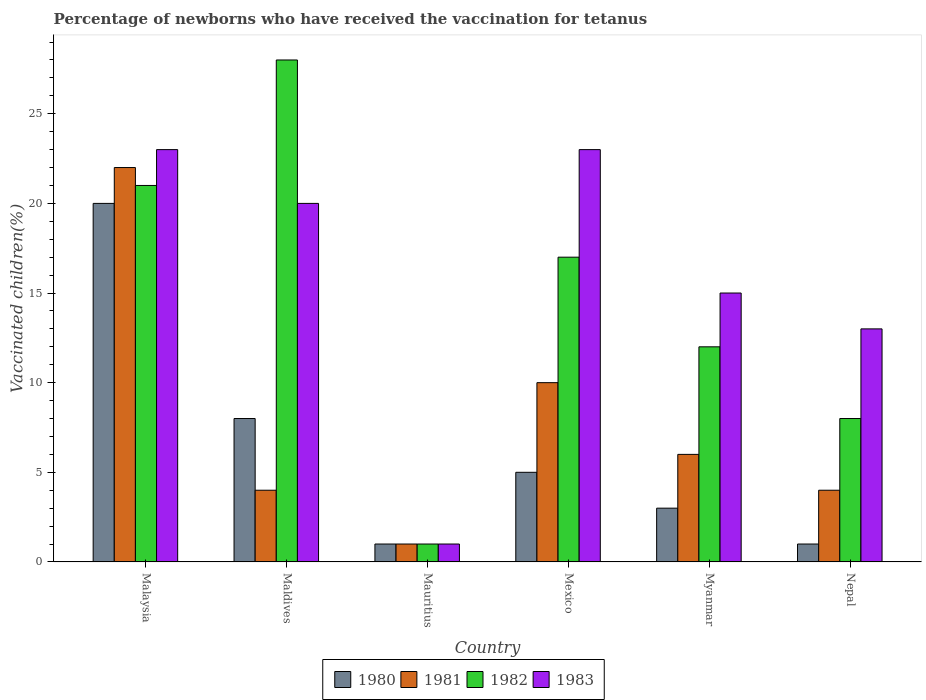Are the number of bars per tick equal to the number of legend labels?
Your response must be concise. Yes. Are the number of bars on each tick of the X-axis equal?
Provide a short and direct response. Yes. How many bars are there on the 3rd tick from the right?
Provide a succinct answer. 4. What is the label of the 6th group of bars from the left?
Make the answer very short. Nepal. What is the percentage of vaccinated children in 1981 in Myanmar?
Your answer should be very brief. 6. In which country was the percentage of vaccinated children in 1982 maximum?
Your answer should be compact. Maldives. In which country was the percentage of vaccinated children in 1983 minimum?
Give a very brief answer. Mauritius. What is the average percentage of vaccinated children in 1980 per country?
Provide a short and direct response. 6.33. What is the difference between the percentage of vaccinated children of/in 1981 and percentage of vaccinated children of/in 1982 in Nepal?
Offer a very short reply. -4. In how many countries, is the percentage of vaccinated children in 1982 greater than 8 %?
Offer a terse response. 4. How many bars are there?
Your answer should be compact. 24. Are the values on the major ticks of Y-axis written in scientific E-notation?
Your answer should be compact. No. How many legend labels are there?
Offer a very short reply. 4. How are the legend labels stacked?
Offer a terse response. Horizontal. What is the title of the graph?
Make the answer very short. Percentage of newborns who have received the vaccination for tetanus. Does "2005" appear as one of the legend labels in the graph?
Your answer should be compact. No. What is the label or title of the X-axis?
Make the answer very short. Country. What is the label or title of the Y-axis?
Your answer should be compact. Vaccinated children(%). What is the Vaccinated children(%) in 1981 in Malaysia?
Give a very brief answer. 22. What is the Vaccinated children(%) of 1980 in Maldives?
Offer a very short reply. 8. What is the Vaccinated children(%) in 1981 in Maldives?
Your answer should be compact. 4. What is the Vaccinated children(%) of 1980 in Mauritius?
Provide a succinct answer. 1. What is the Vaccinated children(%) of 1983 in Mauritius?
Provide a short and direct response. 1. What is the Vaccinated children(%) in 1980 in Mexico?
Your response must be concise. 5. What is the Vaccinated children(%) in 1983 in Mexico?
Make the answer very short. 23. What is the Vaccinated children(%) of 1981 in Myanmar?
Keep it short and to the point. 6. What is the Vaccinated children(%) of 1982 in Myanmar?
Keep it short and to the point. 12. What is the Vaccinated children(%) of 1983 in Myanmar?
Give a very brief answer. 15. What is the Vaccinated children(%) of 1980 in Nepal?
Offer a very short reply. 1. What is the Vaccinated children(%) in 1981 in Nepal?
Make the answer very short. 4. Across all countries, what is the maximum Vaccinated children(%) of 1980?
Provide a short and direct response. 20. Across all countries, what is the maximum Vaccinated children(%) of 1982?
Your answer should be very brief. 28. Across all countries, what is the minimum Vaccinated children(%) of 1980?
Your response must be concise. 1. Across all countries, what is the minimum Vaccinated children(%) of 1982?
Offer a terse response. 1. What is the total Vaccinated children(%) of 1982 in the graph?
Keep it short and to the point. 87. What is the total Vaccinated children(%) of 1983 in the graph?
Offer a very short reply. 95. What is the difference between the Vaccinated children(%) in 1980 in Malaysia and that in Maldives?
Offer a very short reply. 12. What is the difference between the Vaccinated children(%) in 1981 in Malaysia and that in Maldives?
Give a very brief answer. 18. What is the difference between the Vaccinated children(%) of 1980 in Malaysia and that in Mauritius?
Provide a succinct answer. 19. What is the difference between the Vaccinated children(%) of 1983 in Malaysia and that in Mauritius?
Provide a short and direct response. 22. What is the difference between the Vaccinated children(%) in 1983 in Malaysia and that in Mexico?
Keep it short and to the point. 0. What is the difference between the Vaccinated children(%) in 1983 in Malaysia and that in Myanmar?
Make the answer very short. 8. What is the difference between the Vaccinated children(%) of 1980 in Malaysia and that in Nepal?
Keep it short and to the point. 19. What is the difference between the Vaccinated children(%) of 1982 in Malaysia and that in Nepal?
Give a very brief answer. 13. What is the difference between the Vaccinated children(%) in 1983 in Malaysia and that in Nepal?
Provide a succinct answer. 10. What is the difference between the Vaccinated children(%) of 1981 in Maldives and that in Mauritius?
Offer a very short reply. 3. What is the difference between the Vaccinated children(%) of 1982 in Maldives and that in Mauritius?
Provide a short and direct response. 27. What is the difference between the Vaccinated children(%) of 1982 in Maldives and that in Mexico?
Your answer should be compact. 11. What is the difference between the Vaccinated children(%) in 1983 in Maldives and that in Mexico?
Offer a terse response. -3. What is the difference between the Vaccinated children(%) in 1980 in Maldives and that in Myanmar?
Make the answer very short. 5. What is the difference between the Vaccinated children(%) of 1981 in Maldives and that in Myanmar?
Your answer should be compact. -2. What is the difference between the Vaccinated children(%) of 1983 in Maldives and that in Myanmar?
Offer a very short reply. 5. What is the difference between the Vaccinated children(%) of 1980 in Maldives and that in Nepal?
Your response must be concise. 7. What is the difference between the Vaccinated children(%) in 1982 in Maldives and that in Nepal?
Provide a short and direct response. 20. What is the difference between the Vaccinated children(%) of 1983 in Maldives and that in Nepal?
Make the answer very short. 7. What is the difference between the Vaccinated children(%) of 1980 in Mauritius and that in Mexico?
Ensure brevity in your answer.  -4. What is the difference between the Vaccinated children(%) in 1982 in Mauritius and that in Mexico?
Provide a succinct answer. -16. What is the difference between the Vaccinated children(%) in 1980 in Mauritius and that in Nepal?
Provide a short and direct response. 0. What is the difference between the Vaccinated children(%) of 1981 in Mauritius and that in Nepal?
Ensure brevity in your answer.  -3. What is the difference between the Vaccinated children(%) of 1982 in Mauritius and that in Nepal?
Your answer should be compact. -7. What is the difference between the Vaccinated children(%) in 1982 in Mexico and that in Myanmar?
Offer a very short reply. 5. What is the difference between the Vaccinated children(%) of 1981 in Mexico and that in Nepal?
Give a very brief answer. 6. What is the difference between the Vaccinated children(%) of 1983 in Mexico and that in Nepal?
Your answer should be very brief. 10. What is the difference between the Vaccinated children(%) in 1981 in Myanmar and that in Nepal?
Your answer should be compact. 2. What is the difference between the Vaccinated children(%) in 1983 in Myanmar and that in Nepal?
Your answer should be very brief. 2. What is the difference between the Vaccinated children(%) in 1980 in Malaysia and the Vaccinated children(%) in 1981 in Maldives?
Your response must be concise. 16. What is the difference between the Vaccinated children(%) in 1980 in Malaysia and the Vaccinated children(%) in 1983 in Maldives?
Make the answer very short. 0. What is the difference between the Vaccinated children(%) in 1982 in Malaysia and the Vaccinated children(%) in 1983 in Maldives?
Keep it short and to the point. 1. What is the difference between the Vaccinated children(%) in 1980 in Malaysia and the Vaccinated children(%) in 1981 in Mauritius?
Offer a terse response. 19. What is the difference between the Vaccinated children(%) of 1980 in Malaysia and the Vaccinated children(%) of 1982 in Mauritius?
Your response must be concise. 19. What is the difference between the Vaccinated children(%) in 1980 in Malaysia and the Vaccinated children(%) in 1983 in Mauritius?
Make the answer very short. 19. What is the difference between the Vaccinated children(%) of 1981 in Malaysia and the Vaccinated children(%) of 1982 in Mauritius?
Provide a succinct answer. 21. What is the difference between the Vaccinated children(%) in 1981 in Malaysia and the Vaccinated children(%) in 1983 in Mauritius?
Offer a terse response. 21. What is the difference between the Vaccinated children(%) of 1982 in Malaysia and the Vaccinated children(%) of 1983 in Mauritius?
Your answer should be compact. 20. What is the difference between the Vaccinated children(%) in 1980 in Malaysia and the Vaccinated children(%) in 1981 in Mexico?
Keep it short and to the point. 10. What is the difference between the Vaccinated children(%) in 1980 in Malaysia and the Vaccinated children(%) in 1982 in Mexico?
Give a very brief answer. 3. What is the difference between the Vaccinated children(%) of 1980 in Malaysia and the Vaccinated children(%) of 1983 in Mexico?
Provide a succinct answer. -3. What is the difference between the Vaccinated children(%) in 1982 in Malaysia and the Vaccinated children(%) in 1983 in Mexico?
Give a very brief answer. -2. What is the difference between the Vaccinated children(%) of 1980 in Malaysia and the Vaccinated children(%) of 1981 in Myanmar?
Offer a very short reply. 14. What is the difference between the Vaccinated children(%) in 1981 in Malaysia and the Vaccinated children(%) in 1982 in Myanmar?
Ensure brevity in your answer.  10. What is the difference between the Vaccinated children(%) of 1981 in Malaysia and the Vaccinated children(%) of 1983 in Myanmar?
Make the answer very short. 7. What is the difference between the Vaccinated children(%) in 1982 in Malaysia and the Vaccinated children(%) in 1983 in Myanmar?
Your response must be concise. 6. What is the difference between the Vaccinated children(%) of 1980 in Malaysia and the Vaccinated children(%) of 1982 in Nepal?
Keep it short and to the point. 12. What is the difference between the Vaccinated children(%) in 1980 in Malaysia and the Vaccinated children(%) in 1983 in Nepal?
Ensure brevity in your answer.  7. What is the difference between the Vaccinated children(%) in 1980 in Maldives and the Vaccinated children(%) in 1981 in Mauritius?
Make the answer very short. 7. What is the difference between the Vaccinated children(%) of 1981 in Maldives and the Vaccinated children(%) of 1982 in Mauritius?
Your answer should be compact. 3. What is the difference between the Vaccinated children(%) of 1981 in Maldives and the Vaccinated children(%) of 1983 in Mauritius?
Your answer should be very brief. 3. What is the difference between the Vaccinated children(%) in 1982 in Maldives and the Vaccinated children(%) in 1983 in Mauritius?
Make the answer very short. 27. What is the difference between the Vaccinated children(%) of 1980 in Maldives and the Vaccinated children(%) of 1981 in Mexico?
Provide a short and direct response. -2. What is the difference between the Vaccinated children(%) of 1980 in Maldives and the Vaccinated children(%) of 1982 in Mexico?
Provide a short and direct response. -9. What is the difference between the Vaccinated children(%) in 1981 in Maldives and the Vaccinated children(%) in 1982 in Mexico?
Ensure brevity in your answer.  -13. What is the difference between the Vaccinated children(%) of 1982 in Maldives and the Vaccinated children(%) of 1983 in Mexico?
Make the answer very short. 5. What is the difference between the Vaccinated children(%) in 1980 in Maldives and the Vaccinated children(%) in 1981 in Myanmar?
Offer a very short reply. 2. What is the difference between the Vaccinated children(%) of 1981 in Maldives and the Vaccinated children(%) of 1983 in Myanmar?
Provide a succinct answer. -11. What is the difference between the Vaccinated children(%) of 1982 in Maldives and the Vaccinated children(%) of 1983 in Myanmar?
Your answer should be compact. 13. What is the difference between the Vaccinated children(%) of 1980 in Maldives and the Vaccinated children(%) of 1982 in Nepal?
Keep it short and to the point. 0. What is the difference between the Vaccinated children(%) in 1980 in Maldives and the Vaccinated children(%) in 1983 in Nepal?
Offer a very short reply. -5. What is the difference between the Vaccinated children(%) in 1981 in Maldives and the Vaccinated children(%) in 1983 in Nepal?
Your answer should be compact. -9. What is the difference between the Vaccinated children(%) of 1982 in Maldives and the Vaccinated children(%) of 1983 in Nepal?
Your answer should be very brief. 15. What is the difference between the Vaccinated children(%) of 1980 in Mauritius and the Vaccinated children(%) of 1983 in Mexico?
Offer a terse response. -22. What is the difference between the Vaccinated children(%) in 1980 in Mauritius and the Vaccinated children(%) in 1981 in Myanmar?
Make the answer very short. -5. What is the difference between the Vaccinated children(%) of 1980 in Mauritius and the Vaccinated children(%) of 1982 in Myanmar?
Your answer should be very brief. -11. What is the difference between the Vaccinated children(%) in 1980 in Mauritius and the Vaccinated children(%) in 1981 in Nepal?
Keep it short and to the point. -3. What is the difference between the Vaccinated children(%) of 1980 in Mauritius and the Vaccinated children(%) of 1983 in Nepal?
Provide a short and direct response. -12. What is the difference between the Vaccinated children(%) of 1981 in Mauritius and the Vaccinated children(%) of 1983 in Nepal?
Offer a very short reply. -12. What is the difference between the Vaccinated children(%) of 1982 in Mauritius and the Vaccinated children(%) of 1983 in Nepal?
Your answer should be very brief. -12. What is the difference between the Vaccinated children(%) of 1981 in Mexico and the Vaccinated children(%) of 1982 in Myanmar?
Offer a very short reply. -2. What is the difference between the Vaccinated children(%) in 1980 in Mexico and the Vaccinated children(%) in 1981 in Nepal?
Provide a succinct answer. 1. What is the difference between the Vaccinated children(%) of 1980 in Mexico and the Vaccinated children(%) of 1983 in Nepal?
Your answer should be compact. -8. What is the average Vaccinated children(%) of 1980 per country?
Your answer should be compact. 6.33. What is the average Vaccinated children(%) in 1981 per country?
Your answer should be very brief. 7.83. What is the average Vaccinated children(%) of 1982 per country?
Keep it short and to the point. 14.5. What is the average Vaccinated children(%) of 1983 per country?
Offer a very short reply. 15.83. What is the difference between the Vaccinated children(%) in 1980 and Vaccinated children(%) in 1981 in Malaysia?
Ensure brevity in your answer.  -2. What is the difference between the Vaccinated children(%) of 1981 and Vaccinated children(%) of 1983 in Malaysia?
Keep it short and to the point. -1. What is the difference between the Vaccinated children(%) in 1980 and Vaccinated children(%) in 1982 in Maldives?
Keep it short and to the point. -20. What is the difference between the Vaccinated children(%) of 1980 and Vaccinated children(%) of 1983 in Maldives?
Keep it short and to the point. -12. What is the difference between the Vaccinated children(%) in 1981 and Vaccinated children(%) in 1983 in Maldives?
Your answer should be very brief. -16. What is the difference between the Vaccinated children(%) in 1982 and Vaccinated children(%) in 1983 in Maldives?
Provide a short and direct response. 8. What is the difference between the Vaccinated children(%) of 1981 and Vaccinated children(%) of 1983 in Mauritius?
Provide a short and direct response. 0. What is the difference between the Vaccinated children(%) in 1981 and Vaccinated children(%) in 1982 in Mexico?
Make the answer very short. -7. What is the difference between the Vaccinated children(%) in 1980 and Vaccinated children(%) in 1982 in Myanmar?
Give a very brief answer. -9. What is the difference between the Vaccinated children(%) of 1980 and Vaccinated children(%) of 1983 in Myanmar?
Give a very brief answer. -12. What is the difference between the Vaccinated children(%) of 1980 and Vaccinated children(%) of 1983 in Nepal?
Give a very brief answer. -12. What is the ratio of the Vaccinated children(%) in 1982 in Malaysia to that in Maldives?
Provide a short and direct response. 0.75. What is the ratio of the Vaccinated children(%) of 1983 in Malaysia to that in Maldives?
Make the answer very short. 1.15. What is the ratio of the Vaccinated children(%) in 1982 in Malaysia to that in Mauritius?
Keep it short and to the point. 21. What is the ratio of the Vaccinated children(%) in 1981 in Malaysia to that in Mexico?
Keep it short and to the point. 2.2. What is the ratio of the Vaccinated children(%) in 1982 in Malaysia to that in Mexico?
Your answer should be very brief. 1.24. What is the ratio of the Vaccinated children(%) in 1983 in Malaysia to that in Mexico?
Provide a succinct answer. 1. What is the ratio of the Vaccinated children(%) in 1981 in Malaysia to that in Myanmar?
Your answer should be compact. 3.67. What is the ratio of the Vaccinated children(%) of 1982 in Malaysia to that in Myanmar?
Give a very brief answer. 1.75. What is the ratio of the Vaccinated children(%) in 1983 in Malaysia to that in Myanmar?
Give a very brief answer. 1.53. What is the ratio of the Vaccinated children(%) of 1981 in Malaysia to that in Nepal?
Give a very brief answer. 5.5. What is the ratio of the Vaccinated children(%) of 1982 in Malaysia to that in Nepal?
Provide a short and direct response. 2.62. What is the ratio of the Vaccinated children(%) in 1983 in Malaysia to that in Nepal?
Your answer should be compact. 1.77. What is the ratio of the Vaccinated children(%) of 1982 in Maldives to that in Mauritius?
Make the answer very short. 28. What is the ratio of the Vaccinated children(%) of 1983 in Maldives to that in Mauritius?
Offer a very short reply. 20. What is the ratio of the Vaccinated children(%) of 1981 in Maldives to that in Mexico?
Keep it short and to the point. 0.4. What is the ratio of the Vaccinated children(%) in 1982 in Maldives to that in Mexico?
Your answer should be very brief. 1.65. What is the ratio of the Vaccinated children(%) in 1983 in Maldives to that in Mexico?
Ensure brevity in your answer.  0.87. What is the ratio of the Vaccinated children(%) of 1980 in Maldives to that in Myanmar?
Offer a terse response. 2.67. What is the ratio of the Vaccinated children(%) of 1982 in Maldives to that in Myanmar?
Offer a very short reply. 2.33. What is the ratio of the Vaccinated children(%) of 1983 in Maldives to that in Myanmar?
Keep it short and to the point. 1.33. What is the ratio of the Vaccinated children(%) of 1980 in Maldives to that in Nepal?
Ensure brevity in your answer.  8. What is the ratio of the Vaccinated children(%) of 1983 in Maldives to that in Nepal?
Your answer should be very brief. 1.54. What is the ratio of the Vaccinated children(%) of 1980 in Mauritius to that in Mexico?
Offer a terse response. 0.2. What is the ratio of the Vaccinated children(%) of 1981 in Mauritius to that in Mexico?
Make the answer very short. 0.1. What is the ratio of the Vaccinated children(%) in 1982 in Mauritius to that in Mexico?
Provide a short and direct response. 0.06. What is the ratio of the Vaccinated children(%) in 1983 in Mauritius to that in Mexico?
Provide a succinct answer. 0.04. What is the ratio of the Vaccinated children(%) of 1980 in Mauritius to that in Myanmar?
Your response must be concise. 0.33. What is the ratio of the Vaccinated children(%) of 1981 in Mauritius to that in Myanmar?
Provide a short and direct response. 0.17. What is the ratio of the Vaccinated children(%) of 1982 in Mauritius to that in Myanmar?
Ensure brevity in your answer.  0.08. What is the ratio of the Vaccinated children(%) of 1983 in Mauritius to that in Myanmar?
Ensure brevity in your answer.  0.07. What is the ratio of the Vaccinated children(%) of 1980 in Mauritius to that in Nepal?
Your answer should be compact. 1. What is the ratio of the Vaccinated children(%) of 1981 in Mauritius to that in Nepal?
Keep it short and to the point. 0.25. What is the ratio of the Vaccinated children(%) in 1982 in Mauritius to that in Nepal?
Keep it short and to the point. 0.12. What is the ratio of the Vaccinated children(%) in 1983 in Mauritius to that in Nepal?
Keep it short and to the point. 0.08. What is the ratio of the Vaccinated children(%) of 1981 in Mexico to that in Myanmar?
Your answer should be very brief. 1.67. What is the ratio of the Vaccinated children(%) in 1982 in Mexico to that in Myanmar?
Give a very brief answer. 1.42. What is the ratio of the Vaccinated children(%) in 1983 in Mexico to that in Myanmar?
Offer a very short reply. 1.53. What is the ratio of the Vaccinated children(%) in 1980 in Mexico to that in Nepal?
Offer a very short reply. 5. What is the ratio of the Vaccinated children(%) in 1982 in Mexico to that in Nepal?
Ensure brevity in your answer.  2.12. What is the ratio of the Vaccinated children(%) of 1983 in Mexico to that in Nepal?
Your response must be concise. 1.77. What is the ratio of the Vaccinated children(%) of 1980 in Myanmar to that in Nepal?
Offer a terse response. 3. What is the ratio of the Vaccinated children(%) in 1981 in Myanmar to that in Nepal?
Offer a very short reply. 1.5. What is the ratio of the Vaccinated children(%) of 1983 in Myanmar to that in Nepal?
Ensure brevity in your answer.  1.15. What is the difference between the highest and the second highest Vaccinated children(%) in 1980?
Ensure brevity in your answer.  12. What is the difference between the highest and the second highest Vaccinated children(%) in 1981?
Your response must be concise. 12. What is the difference between the highest and the second highest Vaccinated children(%) of 1982?
Offer a very short reply. 7. What is the difference between the highest and the lowest Vaccinated children(%) in 1980?
Keep it short and to the point. 19. What is the difference between the highest and the lowest Vaccinated children(%) in 1981?
Your answer should be compact. 21. What is the difference between the highest and the lowest Vaccinated children(%) of 1983?
Make the answer very short. 22. 